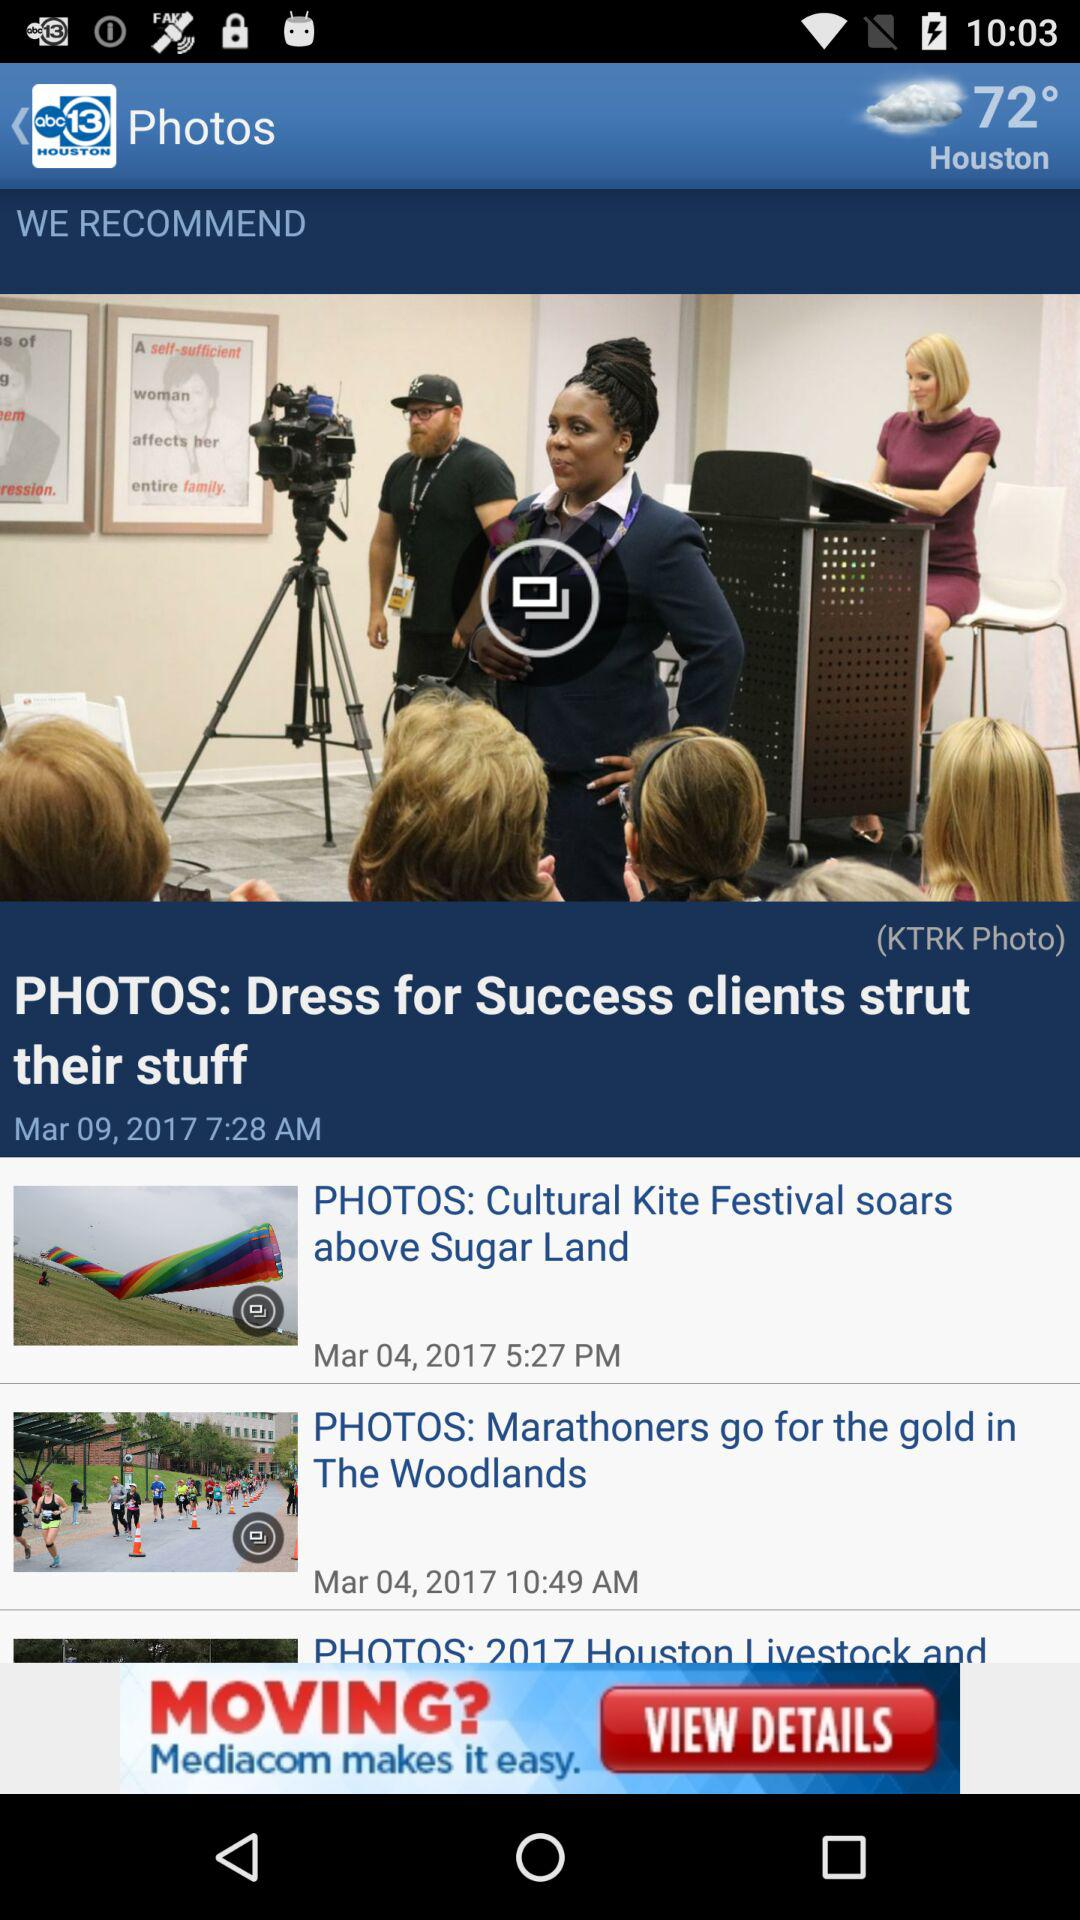At what time was the post "Dress for Success clients strut their stuff" posted? The post "Dress for Success clients strut their stuff" was posted at 7:28 AM. 